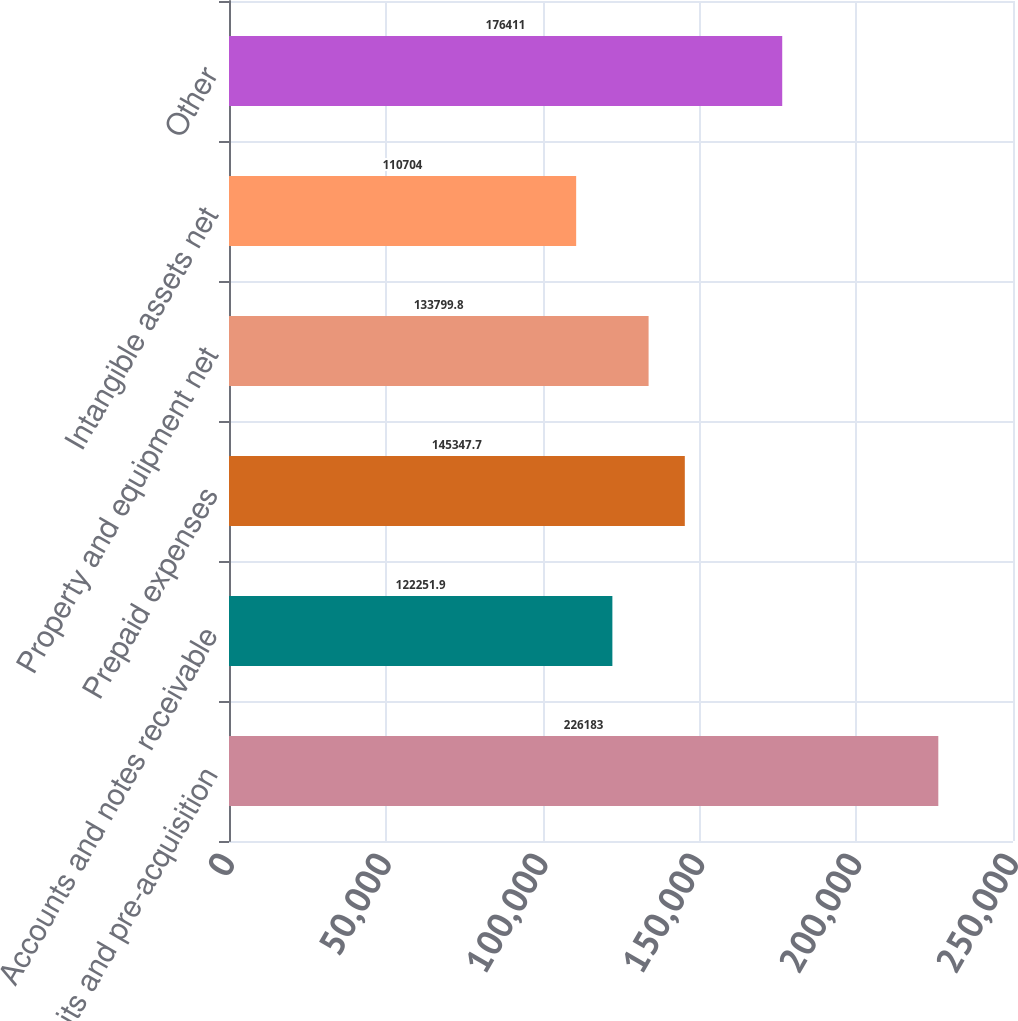Convert chart. <chart><loc_0><loc_0><loc_500><loc_500><bar_chart><fcel>Deposits and pre-acquisition<fcel>Accounts and notes receivable<fcel>Prepaid expenses<fcel>Property and equipment net<fcel>Intangible assets net<fcel>Other<nl><fcel>226183<fcel>122252<fcel>145348<fcel>133800<fcel>110704<fcel>176411<nl></chart> 